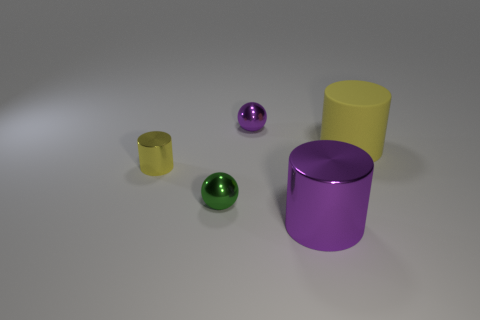Add 1 purple rubber blocks. How many objects exist? 6 Subtract all balls. How many objects are left? 3 Add 3 big purple cylinders. How many big purple cylinders are left? 4 Add 4 tiny yellow metal things. How many tiny yellow metal things exist? 5 Subtract 0 gray cylinders. How many objects are left? 5 Subtract all green objects. Subtract all balls. How many objects are left? 2 